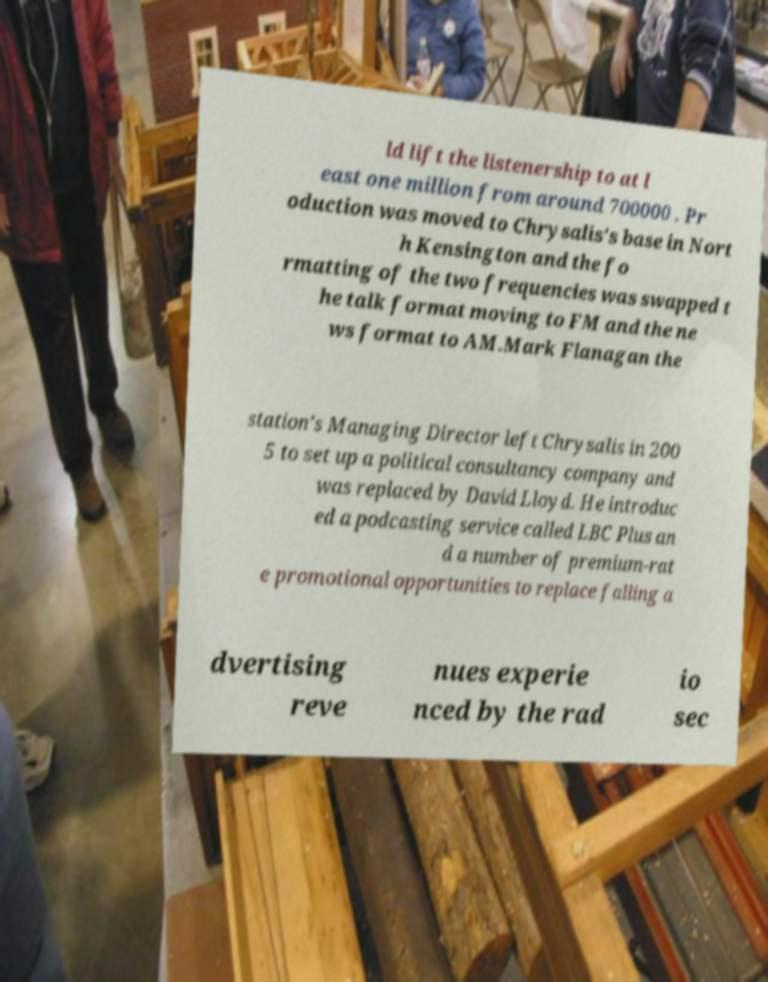Can you accurately transcribe the text from the provided image for me? ld lift the listenership to at l east one million from around 700000 . Pr oduction was moved to Chrysalis's base in Nort h Kensington and the fo rmatting of the two frequencies was swapped t he talk format moving to FM and the ne ws format to AM.Mark Flanagan the station's Managing Director left Chrysalis in 200 5 to set up a political consultancy company and was replaced by David Lloyd. He introduc ed a podcasting service called LBC Plus an d a number of premium-rat e promotional opportunities to replace falling a dvertising reve nues experie nced by the rad io sec 